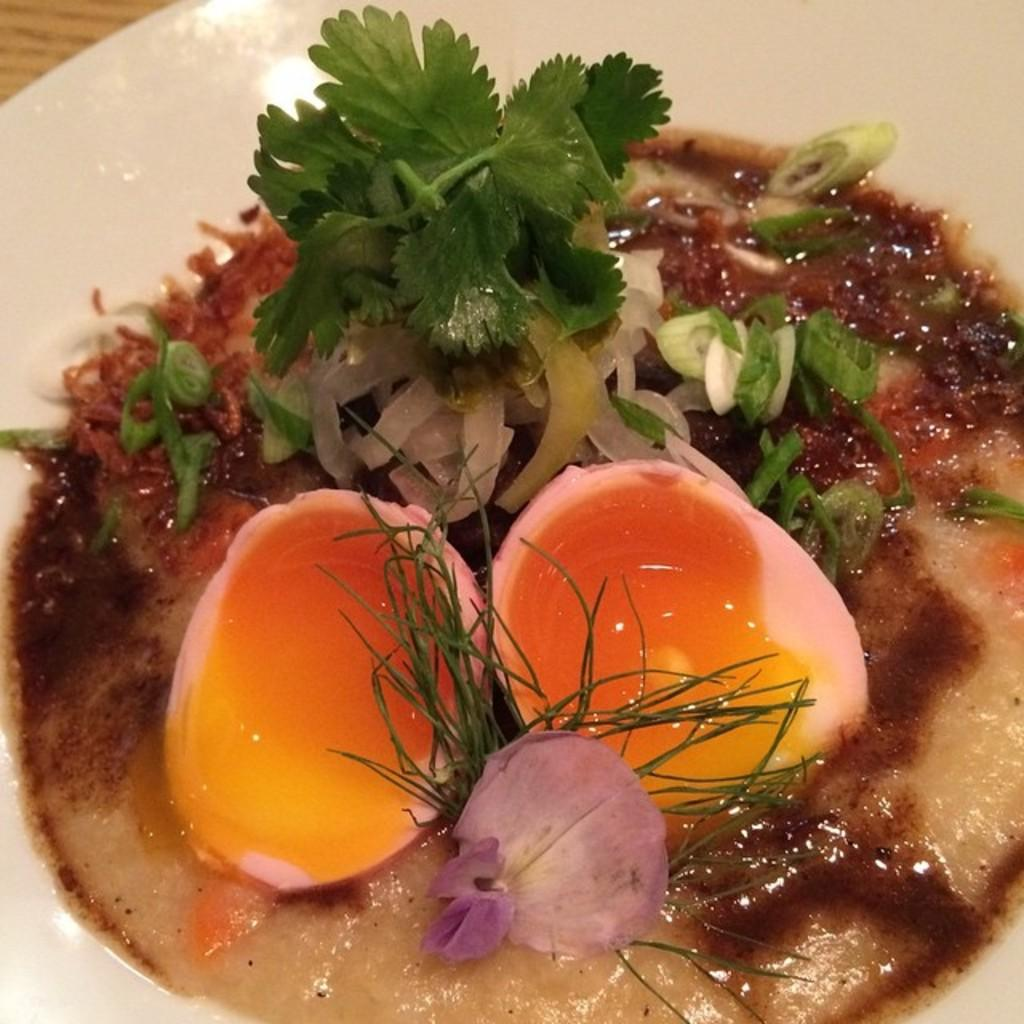What is on the plate that is visible in the image? There is an egg and a slice of onion on the plate. What else can be seen on the plate in the image? There is leafy vegetable on the plate. How many slaves are visible in the image? There are no slaves present in the image. What type of dust can be seen on the plate in the image? There is no dust visible on the plate in the image. 